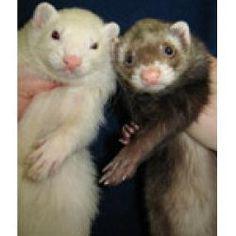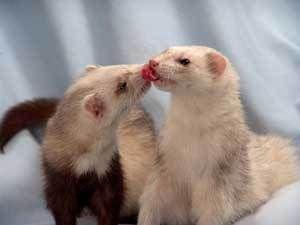The first image is the image on the left, the second image is the image on the right. Assess this claim about the two images: "Three ferrets are sleeping.". Correct or not? Answer yes or no. No. The first image is the image on the left, the second image is the image on the right. Given the left and right images, does the statement "In one of the images, exactly one ferret is sleeping with both eyes and mouth closed." hold true? Answer yes or no. No. 